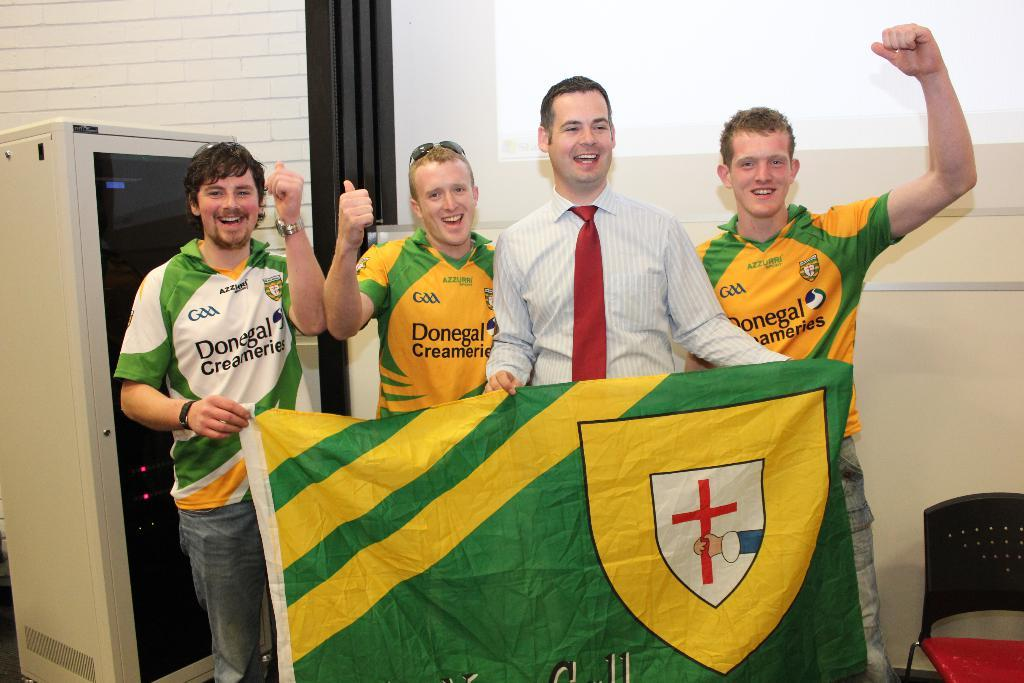<image>
Relay a brief, clear account of the picture shown. Four people, three wearing tops with Donegal Creameries written on it, stand behind a large flag 